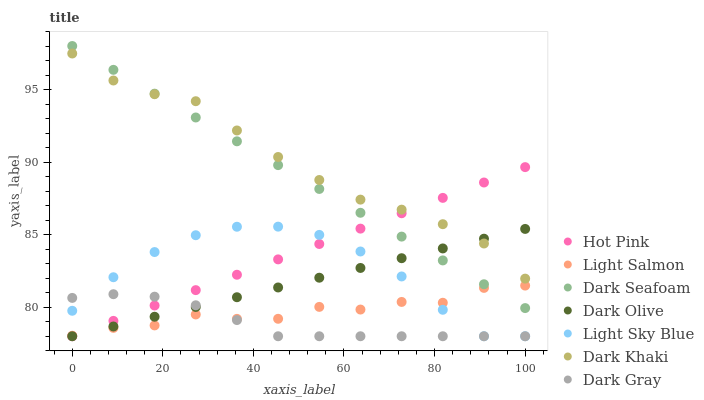Does Dark Gray have the minimum area under the curve?
Answer yes or no. Yes. Does Dark Khaki have the maximum area under the curve?
Answer yes or no. Yes. Does Light Salmon have the minimum area under the curve?
Answer yes or no. No. Does Light Salmon have the maximum area under the curve?
Answer yes or no. No. Is Dark Seafoam the smoothest?
Answer yes or no. Yes. Is Light Salmon the roughest?
Answer yes or no. Yes. Is Hot Pink the smoothest?
Answer yes or no. No. Is Hot Pink the roughest?
Answer yes or no. No. Does Dark Gray have the lowest value?
Answer yes or no. Yes. Does Light Salmon have the lowest value?
Answer yes or no. No. Does Dark Seafoam have the highest value?
Answer yes or no. Yes. Does Light Salmon have the highest value?
Answer yes or no. No. Is Light Sky Blue less than Dark Seafoam?
Answer yes or no. Yes. Is Dark Khaki greater than Light Sky Blue?
Answer yes or no. Yes. Does Dark Olive intersect Light Sky Blue?
Answer yes or no. Yes. Is Dark Olive less than Light Sky Blue?
Answer yes or no. No. Is Dark Olive greater than Light Sky Blue?
Answer yes or no. No. Does Light Sky Blue intersect Dark Seafoam?
Answer yes or no. No. 